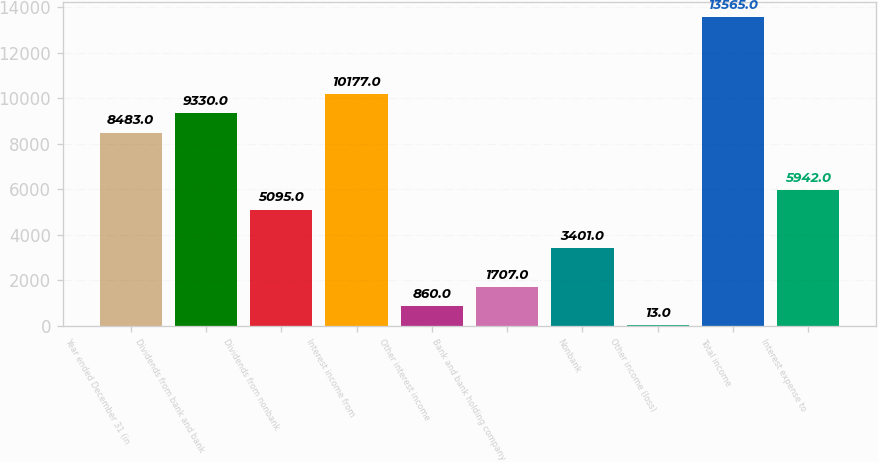Convert chart. <chart><loc_0><loc_0><loc_500><loc_500><bar_chart><fcel>Year ended December 31 (in<fcel>Dividends from bank and bank<fcel>Dividends from nonbank<fcel>Interest income from<fcel>Other interest income<fcel>Bank and bank holding company<fcel>Nonbank<fcel>Other income (loss)<fcel>Total income<fcel>Interest expense to<nl><fcel>8483<fcel>9330<fcel>5095<fcel>10177<fcel>860<fcel>1707<fcel>3401<fcel>13<fcel>13565<fcel>5942<nl></chart> 